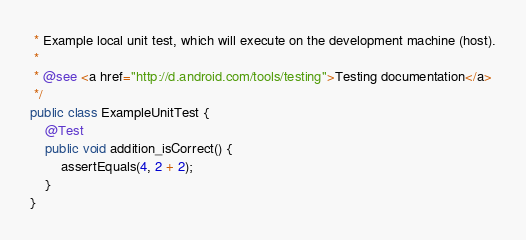<code> <loc_0><loc_0><loc_500><loc_500><_Java_> * Example local unit test, which will execute on the development machine (host).
 *
 * @see <a href="http://d.android.com/tools/testing">Testing documentation</a>
 */
public class ExampleUnitTest {
    @Test
    public void addition_isCorrect() {
        assertEquals(4, 2 + 2);
    }
}</code> 